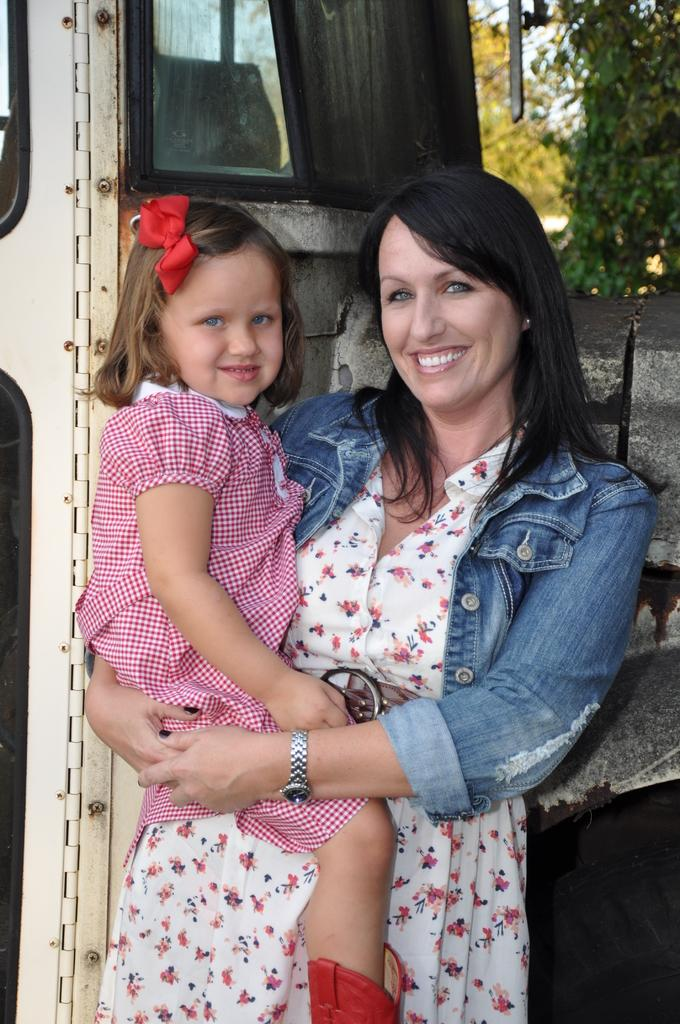Who is the main subject in the image? There is a woman in the image. What is the woman doing in the image? The woman is standing and smiling. What is the woman holding in the image? The woman is holding a girl. What can be seen in the background of the image? There is a vehicle-like object and trees in the background of the image. What type of throne is the actor sitting on in the image? There is no actor or throne present in the image. How many stitches can be seen on the girl's clothing in the image? The image does not provide enough detail to count the stitches on the girl's clothing. 